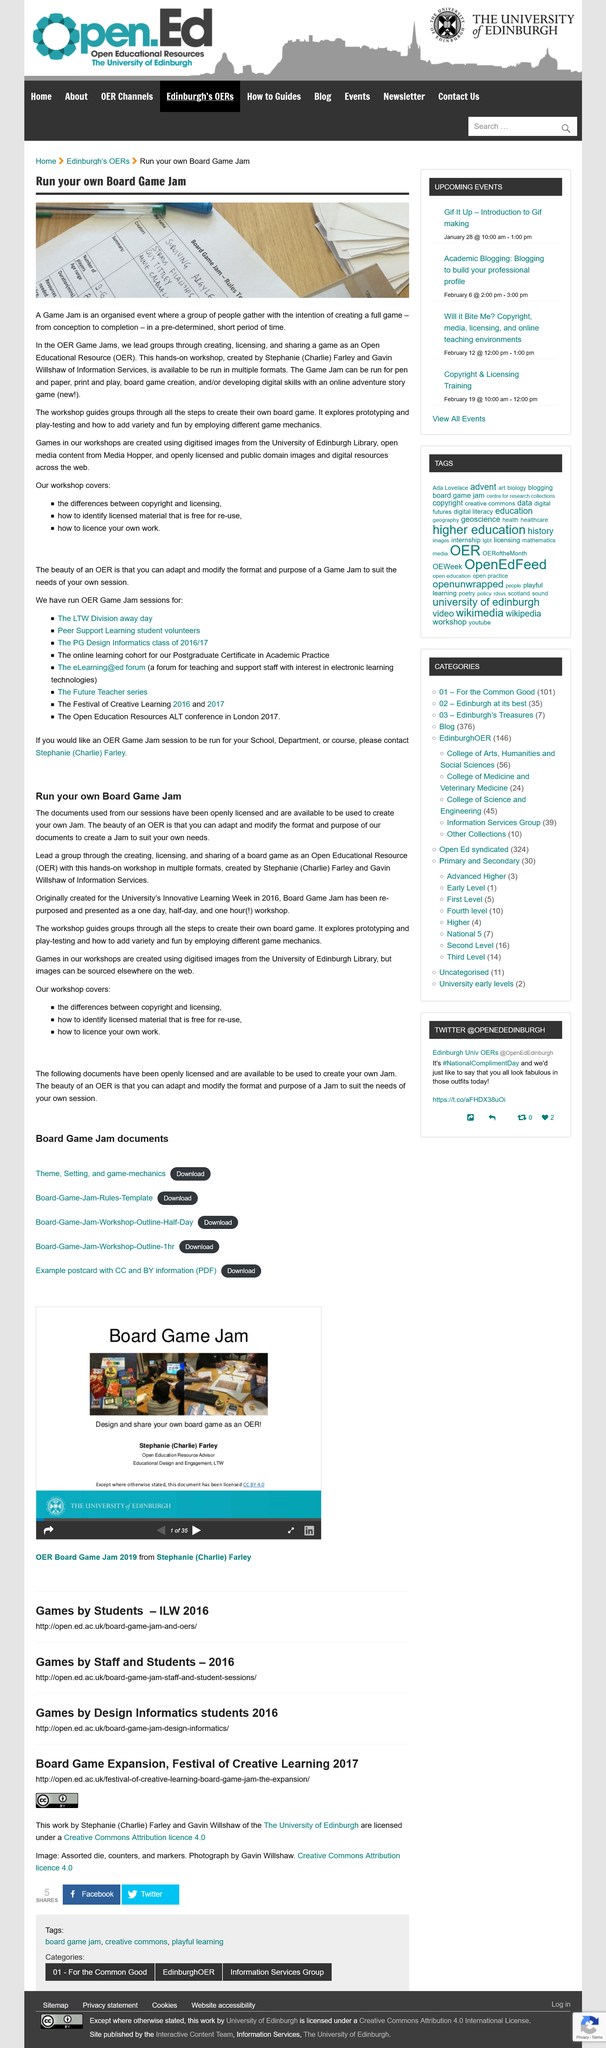Give some essential details in this illustration. Open Educational Resources are acronymized as OER. Yes, games created through Board Game Jams can be shared as Open Educational Resources. It takes a very short amount of time, approximately [insert time frame], to create a game for a Board Game Jam. Games created through Board Game Jams can be in various formats, including but not limited to those created with pen and paper, printed materials, and digital, online resources. For a OER Game Jam session, please contact Stephanie (Charlie) Farley. 